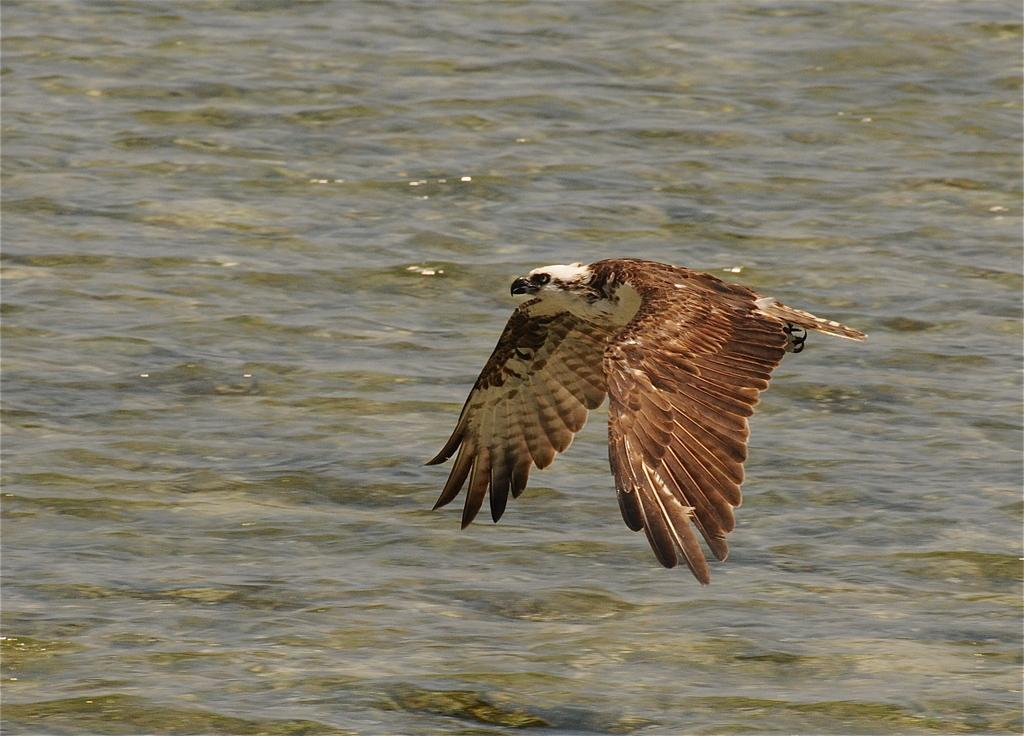What animal is featured in the picture? There is an eagle in the picture. What is the eagle doing in the image? The eagle is flying. What type of landscape can be seen in the image? There is water visible at the bottom of the image. What shape is the eagle attempting to form in the image? The eagle is not attempting to form any specific shape in the image; it is simply flying. 